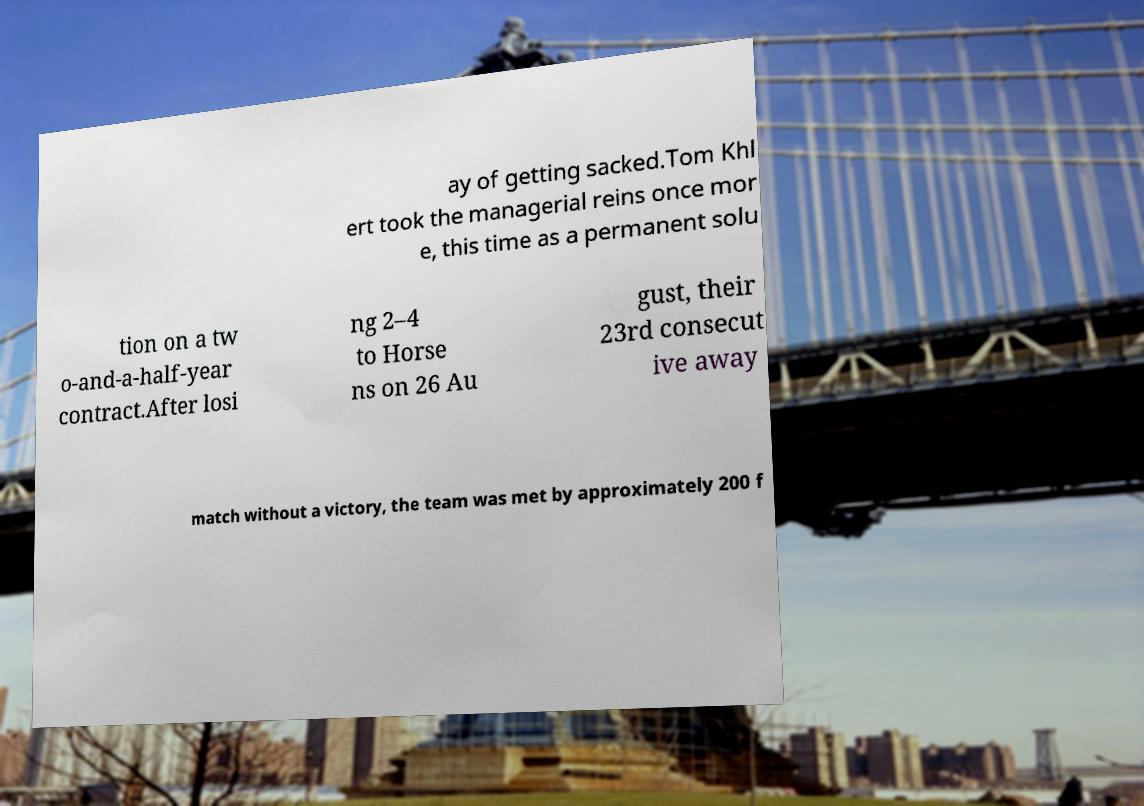There's text embedded in this image that I need extracted. Can you transcribe it verbatim? ay of getting sacked.Tom Khl ert took the managerial reins once mor e, this time as a permanent solu tion on a tw o-and-a-half-year contract.After losi ng 2–4 to Horse ns on 26 Au gust, their 23rd consecut ive away match without a victory, the team was met by approximately 200 f 